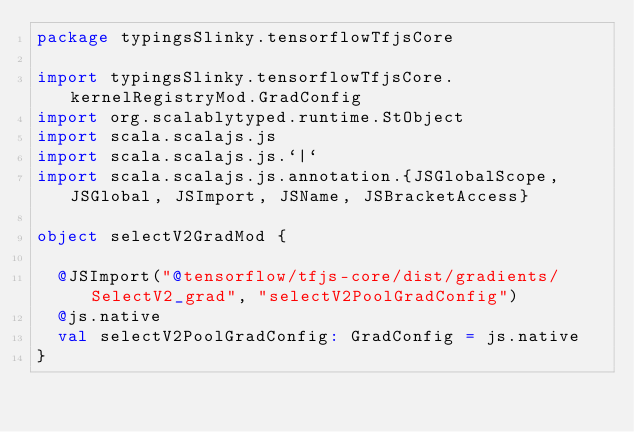<code> <loc_0><loc_0><loc_500><loc_500><_Scala_>package typingsSlinky.tensorflowTfjsCore

import typingsSlinky.tensorflowTfjsCore.kernelRegistryMod.GradConfig
import org.scalablytyped.runtime.StObject
import scala.scalajs.js
import scala.scalajs.js.`|`
import scala.scalajs.js.annotation.{JSGlobalScope, JSGlobal, JSImport, JSName, JSBracketAccess}

object selectV2GradMod {
  
  @JSImport("@tensorflow/tfjs-core/dist/gradients/SelectV2_grad", "selectV2PoolGradConfig")
  @js.native
  val selectV2PoolGradConfig: GradConfig = js.native
}
</code> 